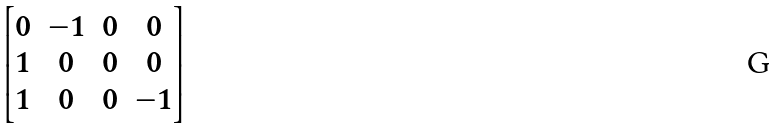<formula> <loc_0><loc_0><loc_500><loc_500>\begin{bmatrix} 0 & - 1 & 0 & 0 \\ 1 & 0 & 0 & 0 \\ 1 & 0 & 0 & - 1 \end{bmatrix}</formula> 